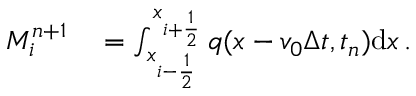<formula> <loc_0><loc_0><loc_500><loc_500>\begin{array} { r l } { M _ { i } ^ { n + 1 } } & = \int _ { x _ { i - \frac { 1 } { 2 } } } ^ { x _ { i + \frac { 1 } { 2 } } } q ( x - v _ { 0 } \Delta t , t _ { n } ) d x \, . } \end{array}</formula> 